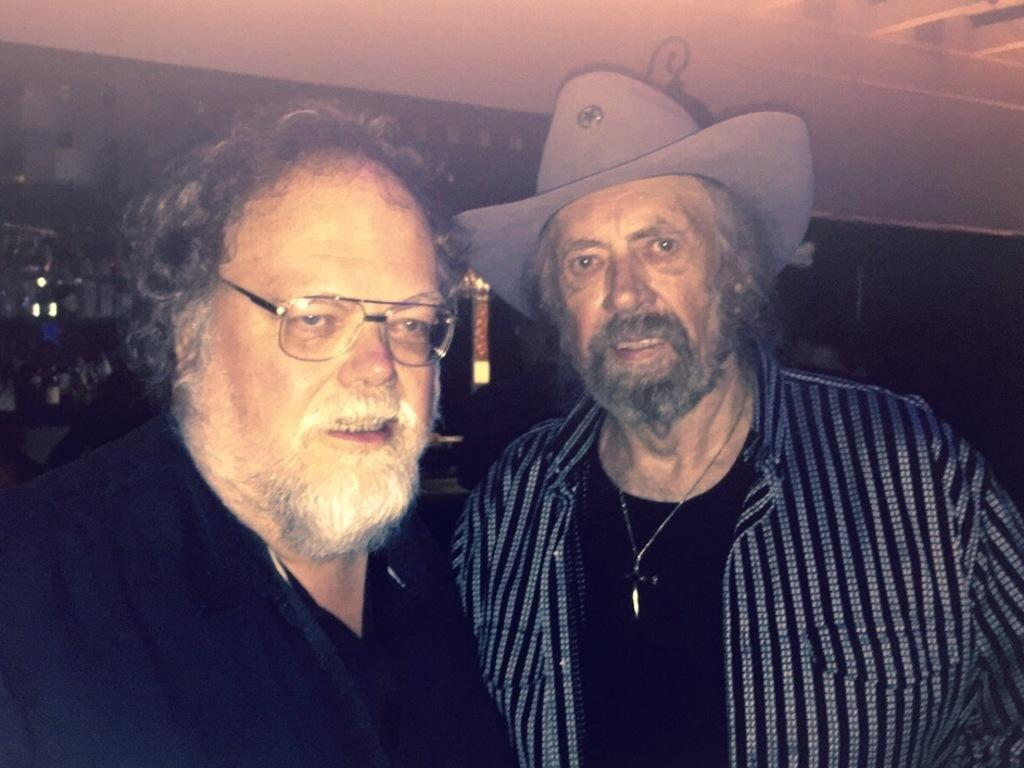What can be observed about the man on the left side of the image? There is a man wearing glasses in the image. What can be seen about the man on the right side of the image? There is another man wearing a hat in the image. Can you describe the background of the image? The background is not clear in the image. What part of the room can be seen at the top of the image? The ceiling is visible at the top of the image. What type of beef is being served on the table in the image? There is no beef present in the image; it only features two men and a background. What kind of metal is used to construct the chairs in the image? There is no information about chairs or their construction in the image. 